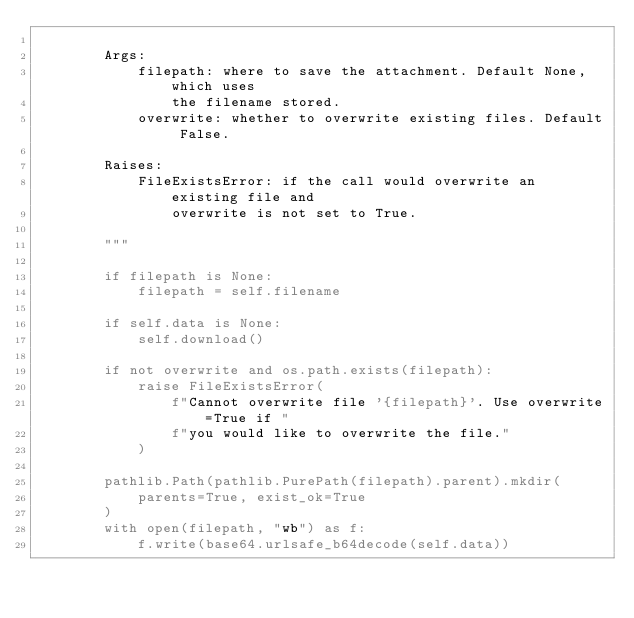Convert code to text. <code><loc_0><loc_0><loc_500><loc_500><_Python_>
        Args:
            filepath: where to save the attachment. Default None, which uses
                the filename stored.
            overwrite: whether to overwrite existing files. Default False.

        Raises:
            FileExistsError: if the call would overwrite an existing file and
                overwrite is not set to True.

        """

        if filepath is None:
            filepath = self.filename

        if self.data is None:
            self.download()

        if not overwrite and os.path.exists(filepath):
            raise FileExistsError(
                f"Cannot overwrite file '{filepath}'. Use overwrite=True if "
                f"you would like to overwrite the file."
            )

        pathlib.Path(pathlib.PurePath(filepath).parent).mkdir(
            parents=True, exist_ok=True
        )
        with open(filepath, "wb") as f:
            f.write(base64.urlsafe_b64decode(self.data))
</code> 